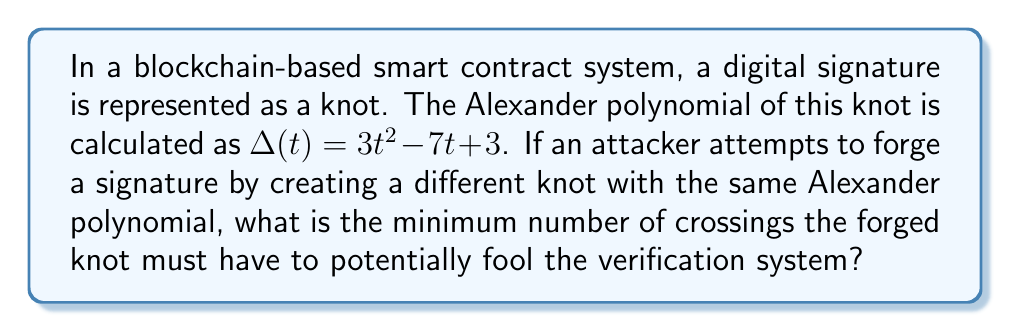Help me with this question. To solve this problem, we need to follow these steps:

1) First, recall that the Alexander polynomial is a knot invariant, meaning it remains unchanged under ambient isotopy. However, it is not a complete invariant, which allows for the possibility of different knots having the same Alexander polynomial.

2) The degree of the Alexander polynomial is related to the crossing number of the knot. Specifically, for a knot K with crossing number c(K), the degree of its Alexander polynomial Δ(t) satisfies:

   $$\text{deg}(\Delta(t)) \leq c(K) - 1$$

3) In our case, the given Alexander polynomial is $\Delta(t) = 3t^2 - 7t + 3$. The degree of this polynomial is 2.

4) Using the inequality from step 2, we can write:

   $$2 \leq c(K) - 1$$

5) Solving for c(K):

   $$c(K) \geq 3$$

6) Therefore, the minimum number of crossings for a knot with this Alexander polynomial is 3.

7) However, the question asks for the minimum number of crossings for a "different" knot with the same Alexander polynomial. The simplest knot with 3 crossings is the trefoil knot, which we can assume is the original signature knot.

8) Thus, to create a different knot with the same Alexander polynomial, the attacker must use a knot with at least 4 crossings.
Answer: 4 crossings 